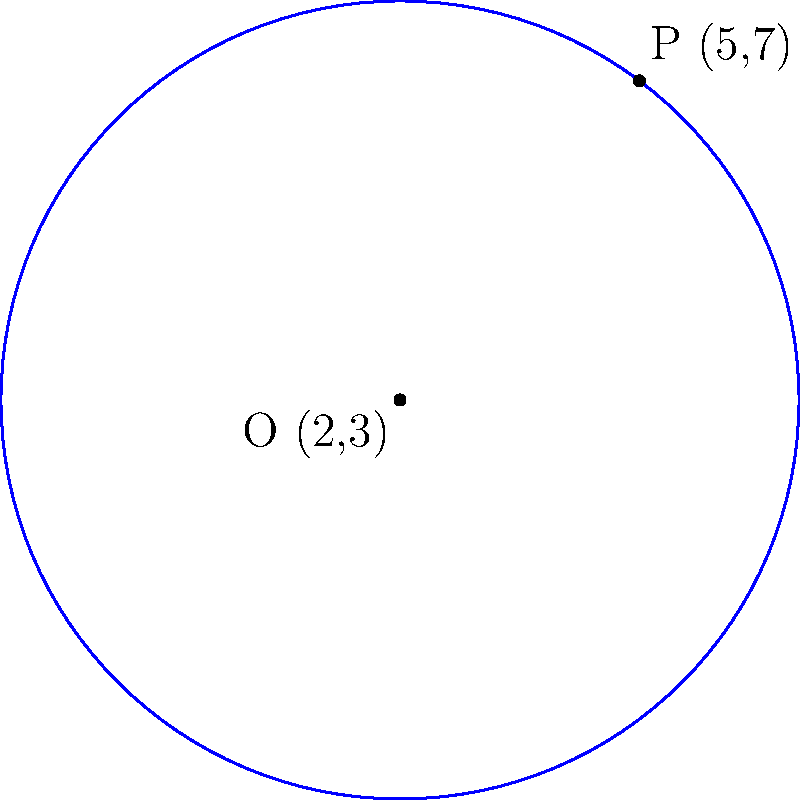As a stay-at-home parent starting a home-based business, you're designing a circular logo for your social media presence. The center of the logo is at (2,3), and a point on its edge is at (5,7). What is the equation of this circle? Let's approach this step-by-step:

1) The general equation of a circle is $$(x-h)^2 + (y-k)^2 = r^2$$
   where (h,k) is the center and r is the radius.

2) We're given the center O(2,3), so h=2 and k=3.

3) To find r, we need to calculate the distance between the center O(2,3) and the point P(5,7) on the circumference:

   $$r^2 = (x_P-x_O)^2 + (y_P-y_O)^2$$
   $$r^2 = (5-2)^2 + (7-3)^2$$
   $$r^2 = 3^2 + 4^2 = 9 + 16 = 25$$
   $$r = 5$$

4) Now we can substitute these values into the general equation:

   $$(x-2)^2 + (y-3)^2 = 5^2$$

5) Simplify:

   $$(x-2)^2 + (y-3)^2 = 25$$

This is the equation of the circle representing your logo.
Answer: $(x-2)^2 + (y-3)^2 = 25$ 